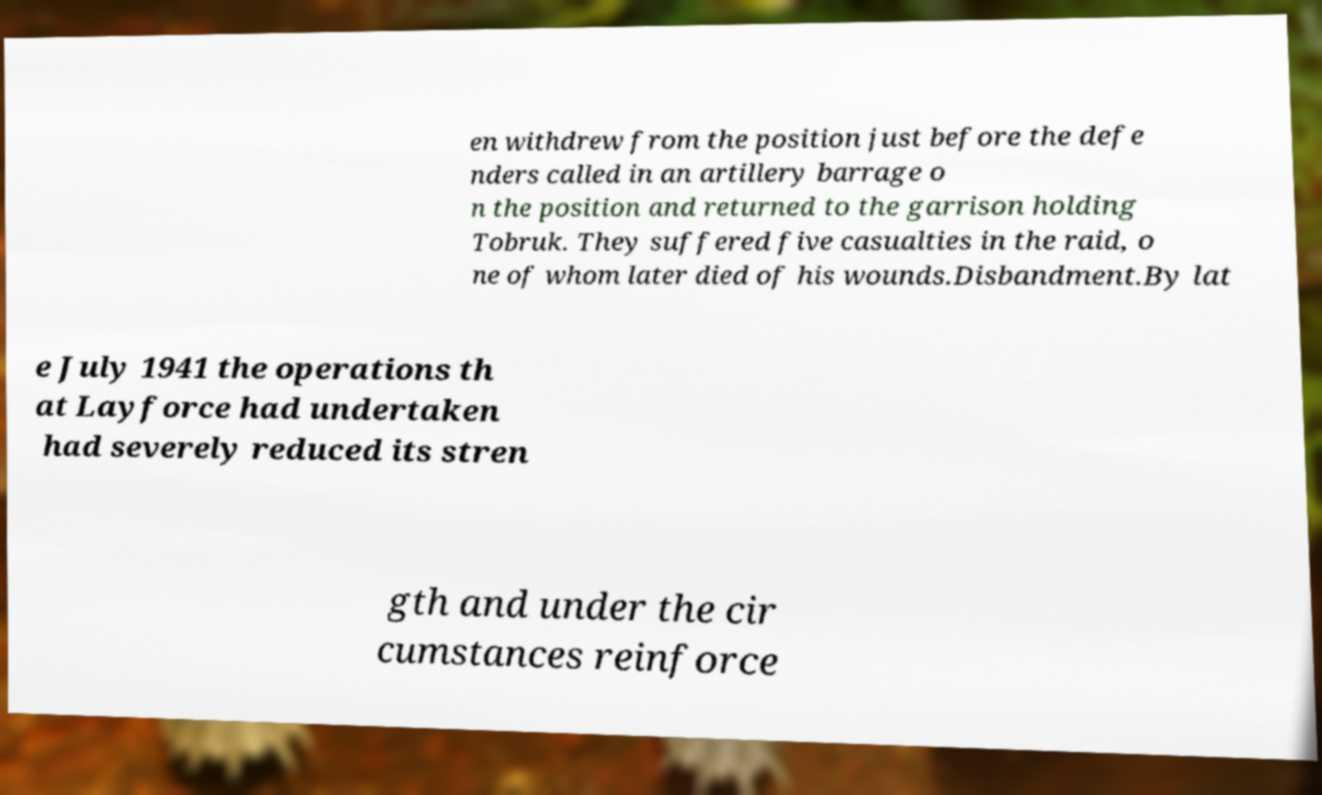Could you assist in decoding the text presented in this image and type it out clearly? en withdrew from the position just before the defe nders called in an artillery barrage o n the position and returned to the garrison holding Tobruk. They suffered five casualties in the raid, o ne of whom later died of his wounds.Disbandment.By lat e July 1941 the operations th at Layforce had undertaken had severely reduced its stren gth and under the cir cumstances reinforce 